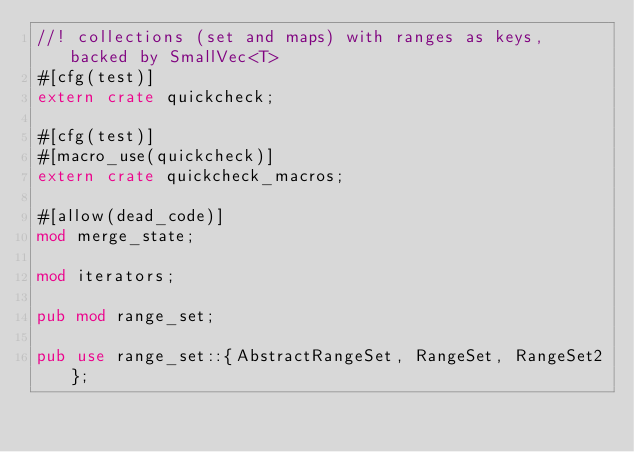Convert code to text. <code><loc_0><loc_0><loc_500><loc_500><_Rust_>//! collections (set and maps) with ranges as keys, backed by SmallVec<T>
#[cfg(test)]
extern crate quickcheck;

#[cfg(test)]
#[macro_use(quickcheck)]
extern crate quickcheck_macros;

#[allow(dead_code)]
mod merge_state;

mod iterators;

pub mod range_set;

pub use range_set::{AbstractRangeSet, RangeSet, RangeSet2};
</code> 